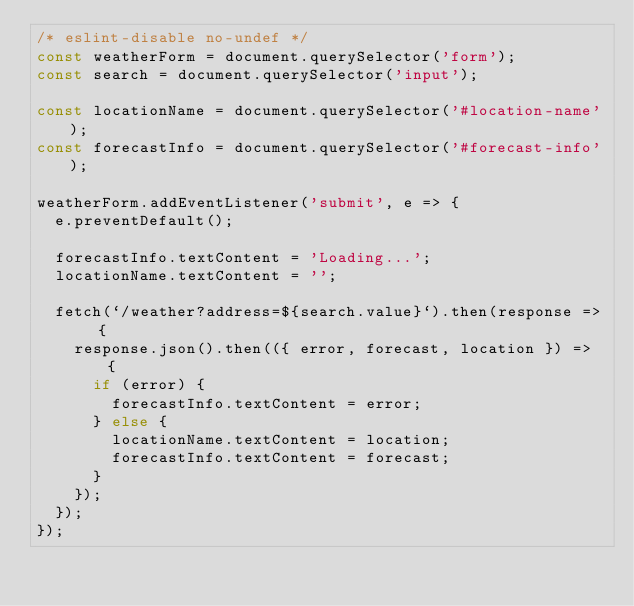Convert code to text. <code><loc_0><loc_0><loc_500><loc_500><_JavaScript_>/* eslint-disable no-undef */
const weatherForm = document.querySelector('form');
const search = document.querySelector('input');

const locationName = document.querySelector('#location-name');
const forecastInfo = document.querySelector('#forecast-info');

weatherForm.addEventListener('submit', e => {
  e.preventDefault();

  forecastInfo.textContent = 'Loading...';
  locationName.textContent = '';

  fetch(`/weather?address=${search.value}`).then(response => {
    response.json().then(({ error, forecast, location }) => {
      if (error) {
        forecastInfo.textContent = error;
      } else {
        locationName.textContent = location;
        forecastInfo.textContent = forecast;
      }
    });
  });
});
</code> 